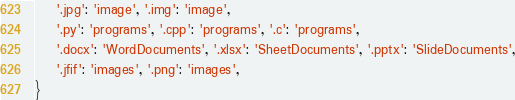<code> <loc_0><loc_0><loc_500><loc_500><_Python_>    '.jpg': 'image', '.img': 'image',
    '.py': 'programs', '.cpp': 'programs', '.c': 'programs',
    '.docx': 'WordDocuments', '.xlsx': 'SheetDocuments', '.pptx': 'SlideDocuments',
    '.jfif': 'images', '.png': 'images',
}
</code> 